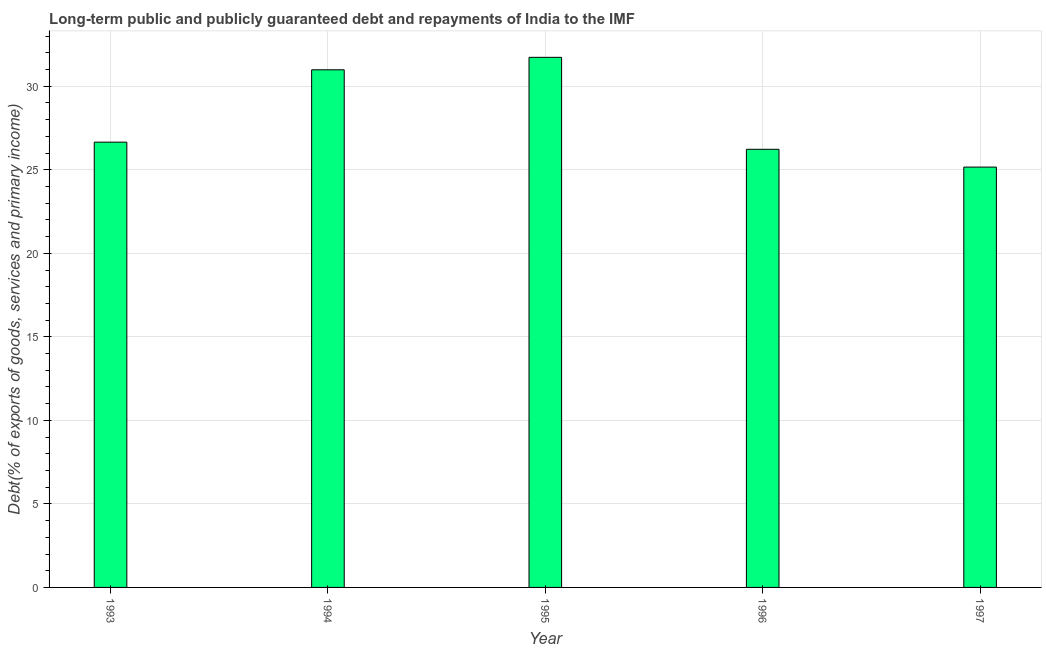Does the graph contain any zero values?
Offer a very short reply. No. What is the title of the graph?
Your response must be concise. Long-term public and publicly guaranteed debt and repayments of India to the IMF. What is the label or title of the Y-axis?
Offer a terse response. Debt(% of exports of goods, services and primary income). What is the debt service in 1995?
Your answer should be very brief. 31.73. Across all years, what is the maximum debt service?
Provide a succinct answer. 31.73. Across all years, what is the minimum debt service?
Offer a very short reply. 25.16. What is the sum of the debt service?
Keep it short and to the point. 140.77. What is the difference between the debt service in 1993 and 1997?
Your response must be concise. 1.49. What is the average debt service per year?
Provide a short and direct response. 28.15. What is the median debt service?
Provide a short and direct response. 26.66. In how many years, is the debt service greater than 19 %?
Make the answer very short. 5. Do a majority of the years between 1994 and 1997 (inclusive) have debt service greater than 14 %?
Offer a very short reply. Yes. What is the ratio of the debt service in 1995 to that in 1997?
Offer a very short reply. 1.26. Is the difference between the debt service in 1995 and 1997 greater than the difference between any two years?
Offer a very short reply. Yes. What is the difference between the highest and the second highest debt service?
Your answer should be very brief. 0.75. Is the sum of the debt service in 1993 and 1996 greater than the maximum debt service across all years?
Keep it short and to the point. Yes. What is the difference between the highest and the lowest debt service?
Provide a short and direct response. 6.57. How many bars are there?
Your answer should be very brief. 5. What is the Debt(% of exports of goods, services and primary income) in 1993?
Ensure brevity in your answer.  26.66. What is the Debt(% of exports of goods, services and primary income) in 1994?
Keep it short and to the point. 30.99. What is the Debt(% of exports of goods, services and primary income) of 1995?
Provide a succinct answer. 31.73. What is the Debt(% of exports of goods, services and primary income) of 1996?
Provide a succinct answer. 26.23. What is the Debt(% of exports of goods, services and primary income) in 1997?
Your response must be concise. 25.16. What is the difference between the Debt(% of exports of goods, services and primary income) in 1993 and 1994?
Offer a terse response. -4.33. What is the difference between the Debt(% of exports of goods, services and primary income) in 1993 and 1995?
Offer a very short reply. -5.08. What is the difference between the Debt(% of exports of goods, services and primary income) in 1993 and 1996?
Provide a short and direct response. 0.43. What is the difference between the Debt(% of exports of goods, services and primary income) in 1993 and 1997?
Make the answer very short. 1.49. What is the difference between the Debt(% of exports of goods, services and primary income) in 1994 and 1995?
Your answer should be very brief. -0.75. What is the difference between the Debt(% of exports of goods, services and primary income) in 1994 and 1996?
Offer a very short reply. 4.76. What is the difference between the Debt(% of exports of goods, services and primary income) in 1994 and 1997?
Offer a terse response. 5.82. What is the difference between the Debt(% of exports of goods, services and primary income) in 1995 and 1996?
Offer a very short reply. 5.5. What is the difference between the Debt(% of exports of goods, services and primary income) in 1995 and 1997?
Offer a very short reply. 6.57. What is the difference between the Debt(% of exports of goods, services and primary income) in 1996 and 1997?
Provide a succinct answer. 1.07. What is the ratio of the Debt(% of exports of goods, services and primary income) in 1993 to that in 1994?
Your answer should be compact. 0.86. What is the ratio of the Debt(% of exports of goods, services and primary income) in 1993 to that in 1995?
Ensure brevity in your answer.  0.84. What is the ratio of the Debt(% of exports of goods, services and primary income) in 1993 to that in 1996?
Your response must be concise. 1.02. What is the ratio of the Debt(% of exports of goods, services and primary income) in 1993 to that in 1997?
Keep it short and to the point. 1.06. What is the ratio of the Debt(% of exports of goods, services and primary income) in 1994 to that in 1995?
Make the answer very short. 0.98. What is the ratio of the Debt(% of exports of goods, services and primary income) in 1994 to that in 1996?
Provide a short and direct response. 1.18. What is the ratio of the Debt(% of exports of goods, services and primary income) in 1994 to that in 1997?
Your answer should be compact. 1.23. What is the ratio of the Debt(% of exports of goods, services and primary income) in 1995 to that in 1996?
Give a very brief answer. 1.21. What is the ratio of the Debt(% of exports of goods, services and primary income) in 1995 to that in 1997?
Make the answer very short. 1.26. What is the ratio of the Debt(% of exports of goods, services and primary income) in 1996 to that in 1997?
Your answer should be very brief. 1.04. 